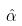Convert formula to latex. <formula><loc_0><loc_0><loc_500><loc_500>\hat { \alpha }</formula> 